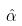Convert formula to latex. <formula><loc_0><loc_0><loc_500><loc_500>\hat { \alpha }</formula> 